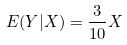Convert formula to latex. <formula><loc_0><loc_0><loc_500><loc_500>E ( Y | X ) = \frac { 3 } { 1 0 } X</formula> 